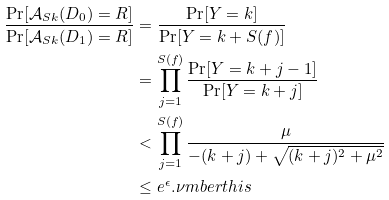Convert formula to latex. <formula><loc_0><loc_0><loc_500><loc_500>\frac { \Pr [ \mathcal { A } _ { S k } ( D _ { 0 } ) = R ] } { \Pr [ \mathcal { A } _ { S k } ( D _ { 1 } ) = R ] } & = \frac { \Pr [ Y = k ] } { \Pr [ Y = k + S ( f ) ] } \\ & = \prod _ { j = 1 } ^ { S ( f ) } \frac { \Pr [ Y = k + j - 1 ] } { \Pr [ Y = k + j ] } \\ & < \prod _ { j = 1 } ^ { S ( f ) } \frac { \mu } { - ( k + j ) + \sqrt { ( k + j ) ^ { 2 } + \mu ^ { 2 } } } \\ & \leq e ^ { \epsilon } . \nu m b e r t h i s</formula> 